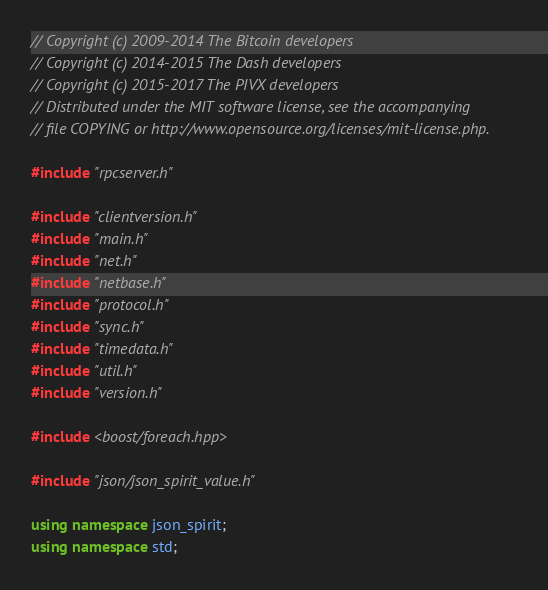Convert code to text. <code><loc_0><loc_0><loc_500><loc_500><_C++_>// Copyright (c) 2009-2014 The Bitcoin developers
// Copyright (c) 2014-2015 The Dash developers
// Copyright (c) 2015-2017 The PIVX developers
// Distributed under the MIT software license, see the accompanying
// file COPYING or http://www.opensource.org/licenses/mit-license.php.

#include "rpcserver.h"

#include "clientversion.h"
#include "main.h"
#include "net.h"
#include "netbase.h"
#include "protocol.h"
#include "sync.h"
#include "timedata.h"
#include "util.h"
#include "version.h"

#include <boost/foreach.hpp>

#include "json/json_spirit_value.h"

using namespace json_spirit;
using namespace std;
</code> 